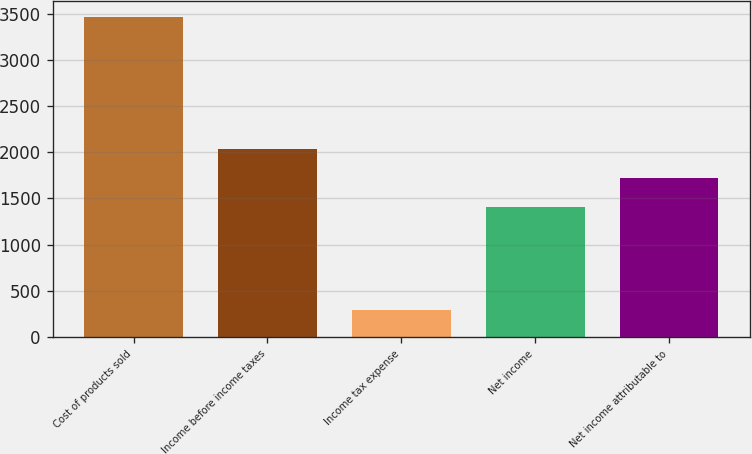Convert chart. <chart><loc_0><loc_0><loc_500><loc_500><bar_chart><fcel>Cost of products sold<fcel>Income before income taxes<fcel>Income tax expense<fcel>Net income<fcel>Net income attributable to<nl><fcel>3466<fcel>2035.6<fcel>293<fcel>1401<fcel>1718.3<nl></chart> 